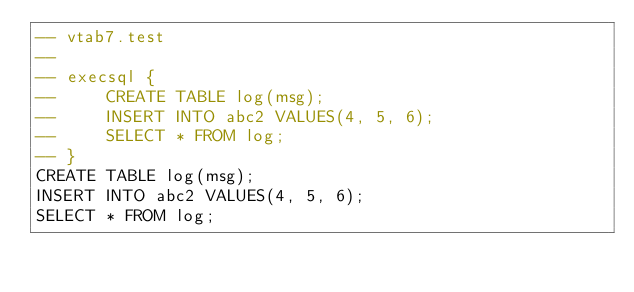Convert code to text. <code><loc_0><loc_0><loc_500><loc_500><_SQL_>-- vtab7.test
-- 
-- execsql {
--     CREATE TABLE log(msg);
--     INSERT INTO abc2 VALUES(4, 5, 6);
--     SELECT * FROM log;
-- }
CREATE TABLE log(msg);
INSERT INTO abc2 VALUES(4, 5, 6);
SELECT * FROM log;</code> 